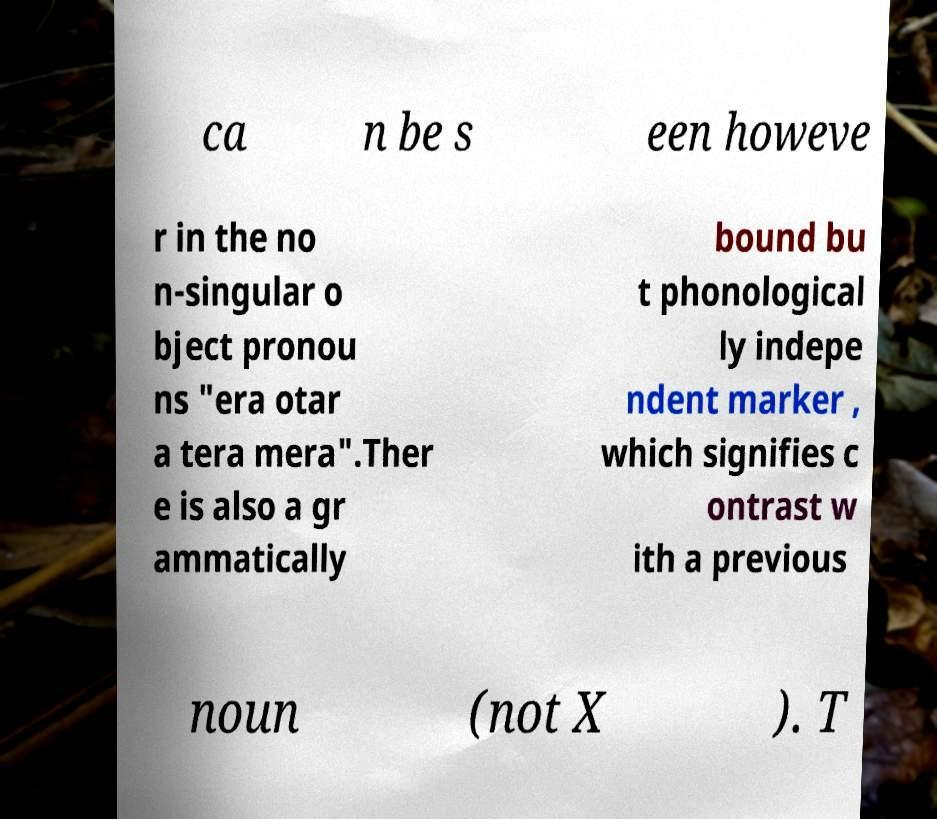Could you assist in decoding the text presented in this image and type it out clearly? ca n be s een howeve r in the no n-singular o bject pronou ns "era otar a tera mera".Ther e is also a gr ammatically bound bu t phonological ly indepe ndent marker , which signifies c ontrast w ith a previous noun (not X ). T 